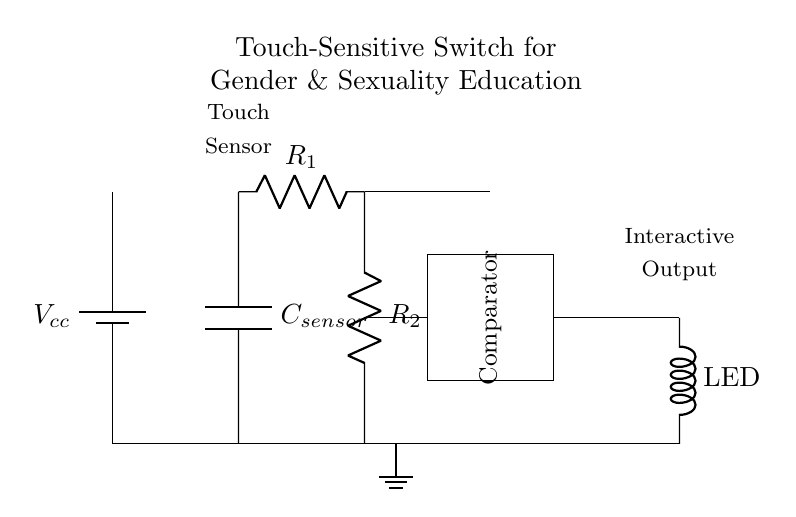What type of sensor is used in this circuit? The circuit diagram clearly labels a component named "C_sensor," which indicates that it is a capacitive sensor. Capacitive sensors detect changes in capacitance when touched.
Answer: capacitive sensor What is the purpose of the LED in this circuit? The LED is used as an interactive output, indicating that the touch-sensitive switch has been activated. When the output is triggered by the comparator, the LED will light up, providing visual feedback.
Answer: interactive output How many resistors are present in the circuit? By examining the circuit diagram, there are two resistors labeled R_1 and R_2. These resistors are part of the resistor network connected to the capacitive sensor.
Answer: two What role does the comparator play in this circuit? The comparator is a critical component that compares the voltage levels from the sensor and the reference voltage. It determines whether the output should be activated or not based on whether the capacitance indicates a touch.
Answer: voltage comparison If the voltage across the battery is five volts, what is the input voltage range at the touch sensor? The input voltage at the sensor will vary between zero volts and the supply voltage, which is five volts. The actual voltage will depend on the capacitance detected when a touch occurs.
Answer: zero to five volts Which component provides the grounding in this circuit? The circuit diagram shows a grounding symbol connected to the lower part of the circuit that links to the common ground. This is where all voltages are referenced against.
Answer: ground What component indicates a change in the electrical state of the circuit? The LED indicates a change in the electrical state by lighting up when the output is activated by the comparator following a detected touch on the capacitive sensor.
Answer: LED 